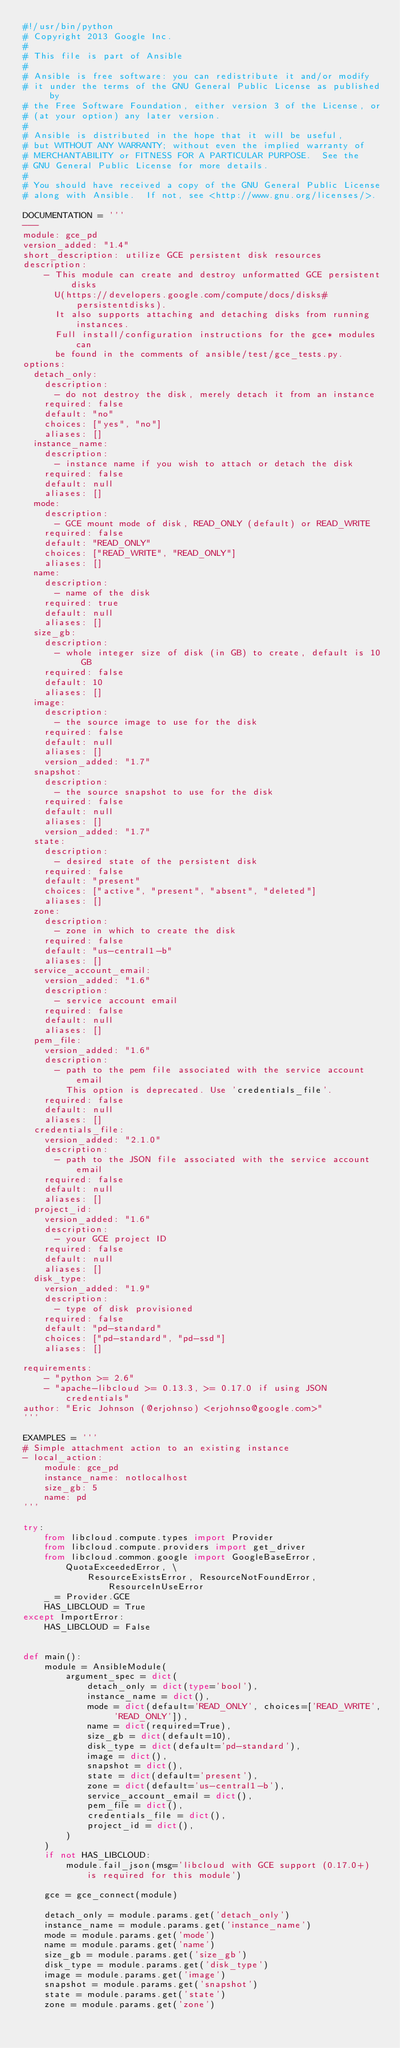Convert code to text. <code><loc_0><loc_0><loc_500><loc_500><_Python_>#!/usr/bin/python
# Copyright 2013 Google Inc.
#
# This file is part of Ansible
#
# Ansible is free software: you can redistribute it and/or modify
# it under the terms of the GNU General Public License as published by
# the Free Software Foundation, either version 3 of the License, or
# (at your option) any later version.
#
# Ansible is distributed in the hope that it will be useful,
# but WITHOUT ANY WARRANTY; without even the implied warranty of
# MERCHANTABILITY or FITNESS FOR A PARTICULAR PURPOSE.  See the
# GNU General Public License for more details.
#
# You should have received a copy of the GNU General Public License
# along with Ansible.  If not, see <http://www.gnu.org/licenses/>.

DOCUMENTATION = '''
---
module: gce_pd
version_added: "1.4"
short_description: utilize GCE persistent disk resources
description:
    - This module can create and destroy unformatted GCE persistent disks
      U(https://developers.google.com/compute/docs/disks#persistentdisks).
      It also supports attaching and detaching disks from running instances.
      Full install/configuration instructions for the gce* modules can
      be found in the comments of ansible/test/gce_tests.py.
options:
  detach_only:
    description:
      - do not destroy the disk, merely detach it from an instance
    required: false
    default: "no"
    choices: ["yes", "no"]
    aliases: []
  instance_name:
    description:
      - instance name if you wish to attach or detach the disk 
    required: false
    default: null 
    aliases: []
  mode:
    description:
      - GCE mount mode of disk, READ_ONLY (default) or READ_WRITE
    required: false
    default: "READ_ONLY" 
    choices: ["READ_WRITE", "READ_ONLY"]
    aliases: []
  name:
    description:
      - name of the disk
    required: true
    default: null 
    aliases: []
  size_gb:
    description:
      - whole integer size of disk (in GB) to create, default is 10 GB
    required: false
    default: 10
    aliases: []
  image:
    description:
      - the source image to use for the disk
    required: false
    default: null
    aliases: []
    version_added: "1.7"
  snapshot:
    description:
      - the source snapshot to use for the disk
    required: false
    default: null
    aliases: []
    version_added: "1.7"
  state:
    description:
      - desired state of the persistent disk
    required: false
    default: "present"
    choices: ["active", "present", "absent", "deleted"]
    aliases: []
  zone:
    description:
      - zone in which to create the disk
    required: false
    default: "us-central1-b"
    aliases: []
  service_account_email:
    version_added: "1.6"
    description:
      - service account email
    required: false
    default: null
    aliases: []
  pem_file:
    version_added: "1.6"
    description:
      - path to the pem file associated with the service account email
        This option is deprecated. Use 'credentials_file'.
    required: false
    default: null
    aliases: []
  credentials_file:
    version_added: "2.1.0"
    description:
      - path to the JSON file associated with the service account email
    required: false
    default: null
    aliases: []
  project_id:
    version_added: "1.6"
    description:
      - your GCE project ID
    required: false
    default: null
    aliases: []
  disk_type:
    version_added: "1.9"
    description:
      - type of disk provisioned
    required: false
    default: "pd-standard"
    choices: ["pd-standard", "pd-ssd"]
    aliases: []

requirements:
    - "python >= 2.6"
    - "apache-libcloud >= 0.13.3, >= 0.17.0 if using JSON credentials"
author: "Eric Johnson (@erjohnso) <erjohnso@google.com>"
'''

EXAMPLES = '''
# Simple attachment action to an existing instance
- local_action:
    module: gce_pd
    instance_name: notlocalhost
    size_gb: 5
    name: pd
'''

try:
    from libcloud.compute.types import Provider
    from libcloud.compute.providers import get_driver
    from libcloud.common.google import GoogleBaseError, QuotaExceededError, \
            ResourceExistsError, ResourceNotFoundError, ResourceInUseError
    _ = Provider.GCE
    HAS_LIBCLOUD = True
except ImportError:
    HAS_LIBCLOUD = False


def main():
    module = AnsibleModule(
        argument_spec = dict(
            detach_only = dict(type='bool'),
            instance_name = dict(),
            mode = dict(default='READ_ONLY', choices=['READ_WRITE', 'READ_ONLY']),
            name = dict(required=True),
            size_gb = dict(default=10),
            disk_type = dict(default='pd-standard'),
            image = dict(),
            snapshot = dict(),
            state = dict(default='present'),
            zone = dict(default='us-central1-b'),
            service_account_email = dict(),
            pem_file = dict(),
            credentials_file = dict(),
            project_id = dict(),
        )
    )
    if not HAS_LIBCLOUD:
        module.fail_json(msg='libcloud with GCE support (0.17.0+) is required for this module')

    gce = gce_connect(module)

    detach_only = module.params.get('detach_only')
    instance_name = module.params.get('instance_name')
    mode = module.params.get('mode')
    name = module.params.get('name')
    size_gb = module.params.get('size_gb')
    disk_type = module.params.get('disk_type')
    image = module.params.get('image')
    snapshot = module.params.get('snapshot')
    state = module.params.get('state')
    zone = module.params.get('zone')
</code> 